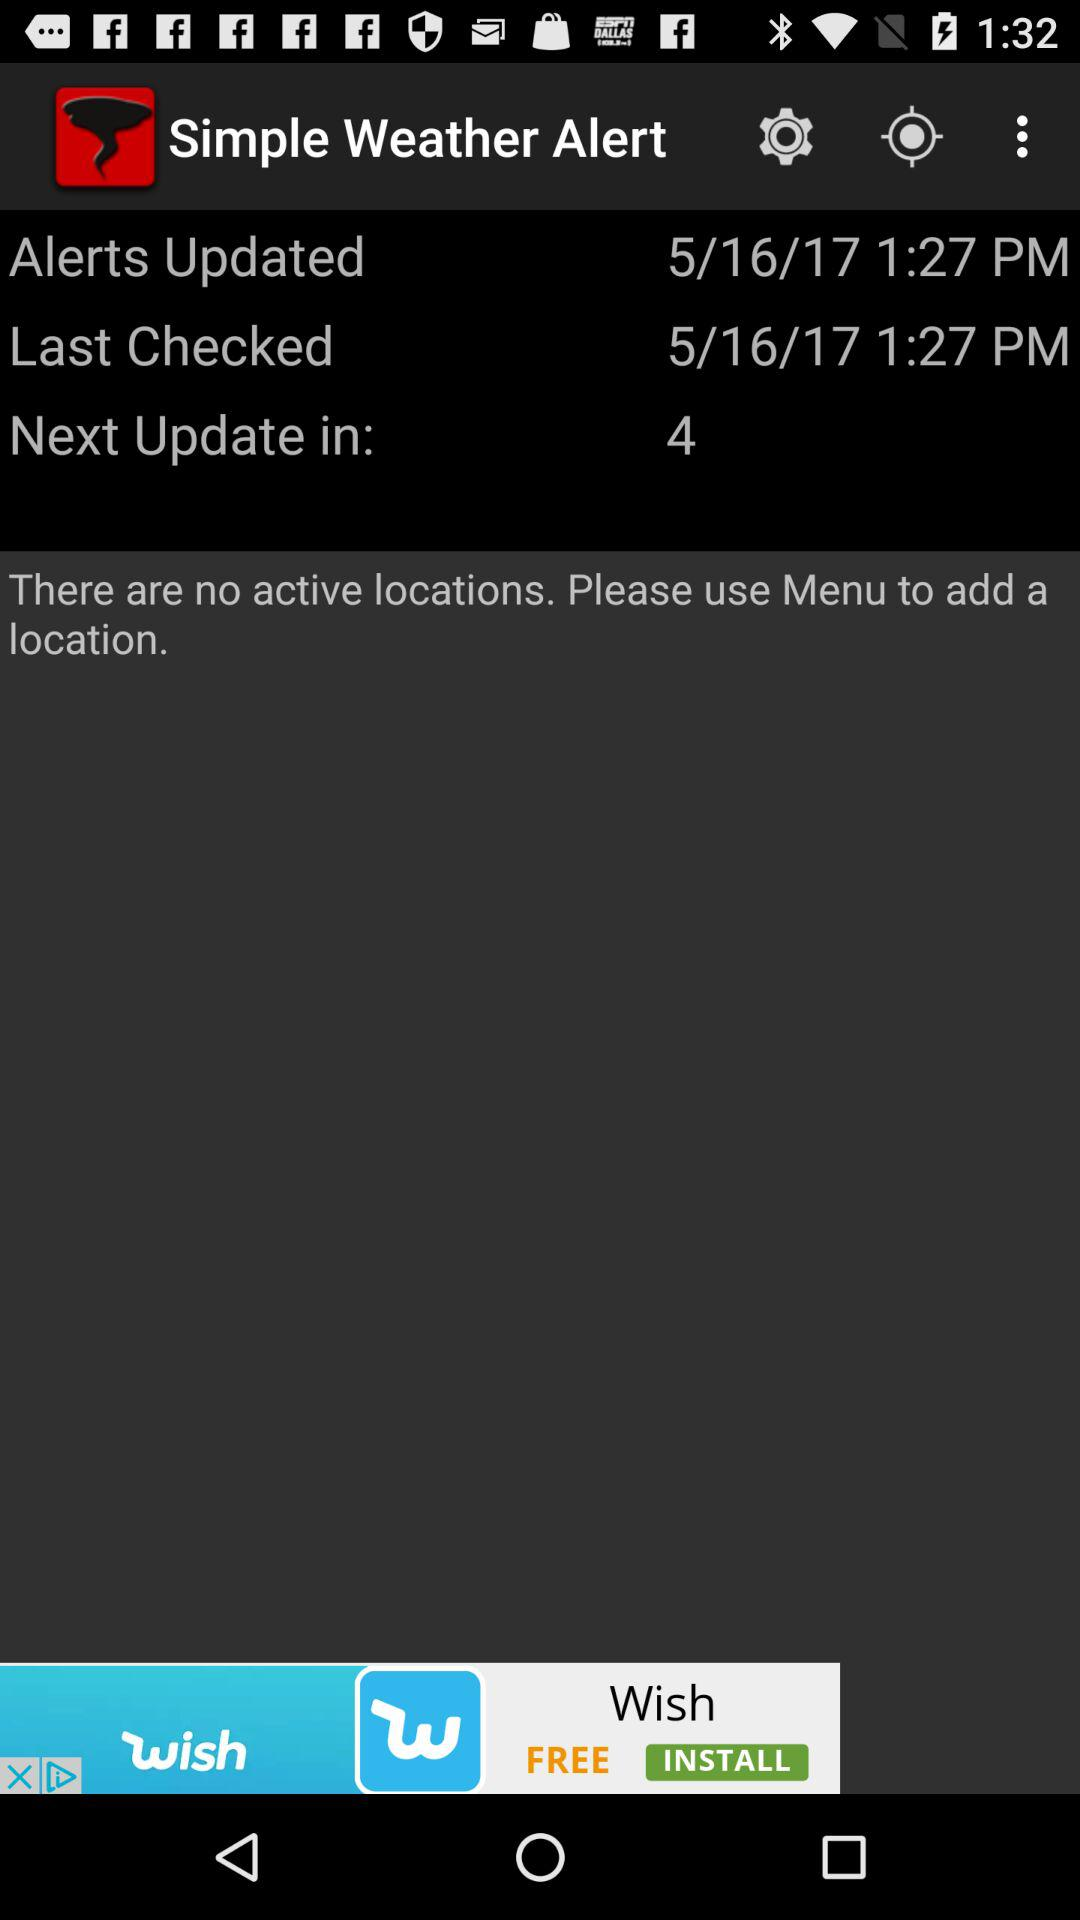What to do to add a location? To add a location, please use the menu. 